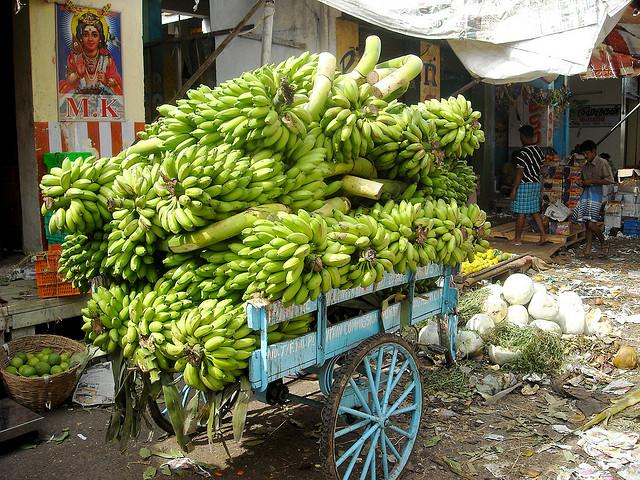What religion is common in this area? Please explain your reasoning. hinduism. The religion is hinduism. 